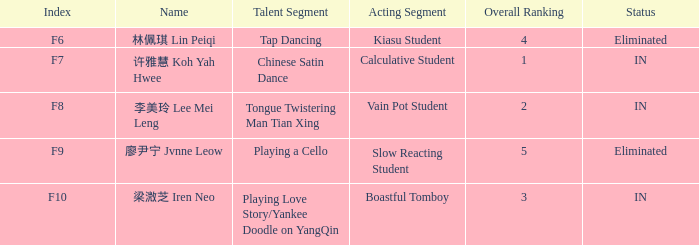For the happening with index f9, what's the skill segment? Playing a Cello. 